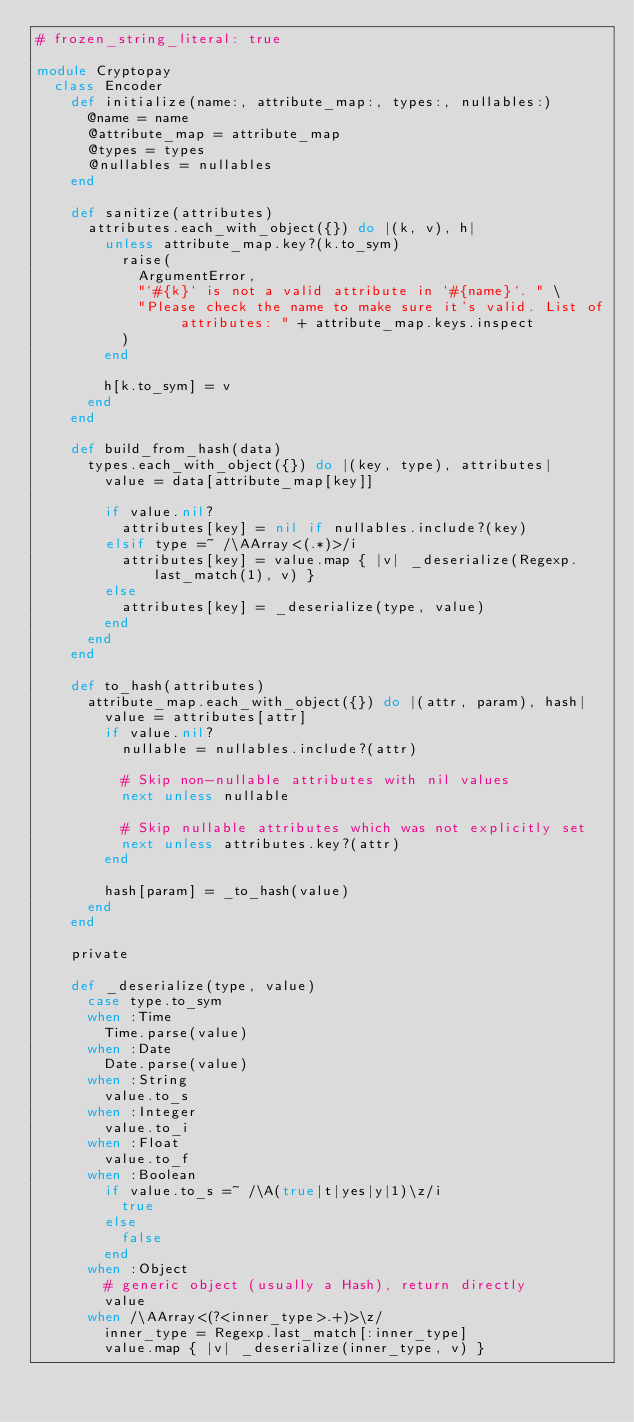<code> <loc_0><loc_0><loc_500><loc_500><_Ruby_># frozen_string_literal: true

module Cryptopay
  class Encoder
    def initialize(name:, attribute_map:, types:, nullables:)
      @name = name
      @attribute_map = attribute_map
      @types = types
      @nullables = nullables
    end

    def sanitize(attributes)
      attributes.each_with_object({}) do |(k, v), h|
        unless attribute_map.key?(k.to_sym)
          raise(
            ArgumentError,
            "`#{k}` is not a valid attribute in `#{name}`. " \
            "Please check the name to make sure it's valid. List of attributes: " + attribute_map.keys.inspect
          )
        end

        h[k.to_sym] = v
      end
    end

    def build_from_hash(data)
      types.each_with_object({}) do |(key, type), attributes|
        value = data[attribute_map[key]]

        if value.nil?
          attributes[key] = nil if nullables.include?(key)
        elsif type =~ /\AArray<(.*)>/i
          attributes[key] = value.map { |v| _deserialize(Regexp.last_match(1), v) }
        else
          attributes[key] = _deserialize(type, value)
        end
      end
    end

    def to_hash(attributes)
      attribute_map.each_with_object({}) do |(attr, param), hash|
        value = attributes[attr]
        if value.nil?
          nullable = nullables.include?(attr)

          # Skip non-nullable attributes with nil values
          next unless nullable

          # Skip nullable attributes which was not explicitly set
          next unless attributes.key?(attr)
        end

        hash[param] = _to_hash(value)
      end
    end

    private

    def _deserialize(type, value)
      case type.to_sym
      when :Time
        Time.parse(value)
      when :Date
        Date.parse(value)
      when :String
        value.to_s
      when :Integer
        value.to_i
      when :Float
        value.to_f
      when :Boolean
        if value.to_s =~ /\A(true|t|yes|y|1)\z/i
          true
        else
          false
        end
      when :Object
        # generic object (usually a Hash), return directly
        value
      when /\AArray<(?<inner_type>.+)>\z/
        inner_type = Regexp.last_match[:inner_type]
        value.map { |v| _deserialize(inner_type, v) }</code> 